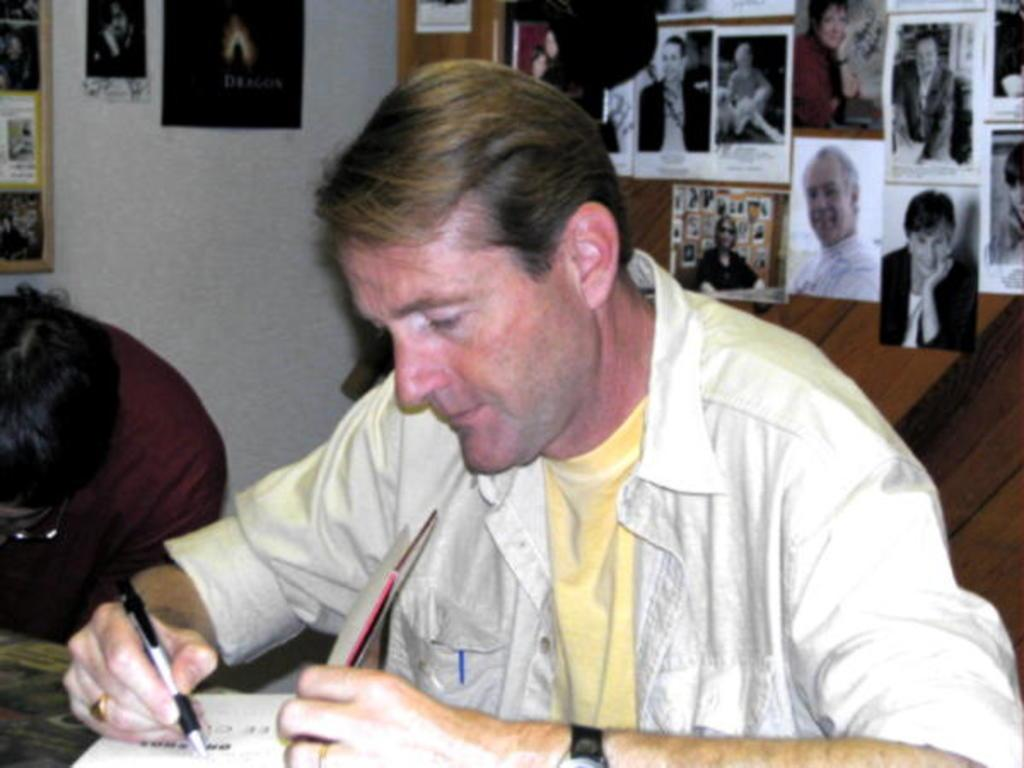Who is in the image? There is a man in the image. What is the man wearing? The man is wearing a yellow shirt. Where is the man sitting in the image? The man is sitting in front of a table. What is on the table? There is a book on the table. What is the man doing with the book? The man is writing on the book. What can be seen on the wall behind the man? There are photographs on the wall behind the man. What type of bat is flying around the room in the image? There is no bat present in the image; it only features a man, a table, a book, photographs on the wall, and a yellow shirt. 